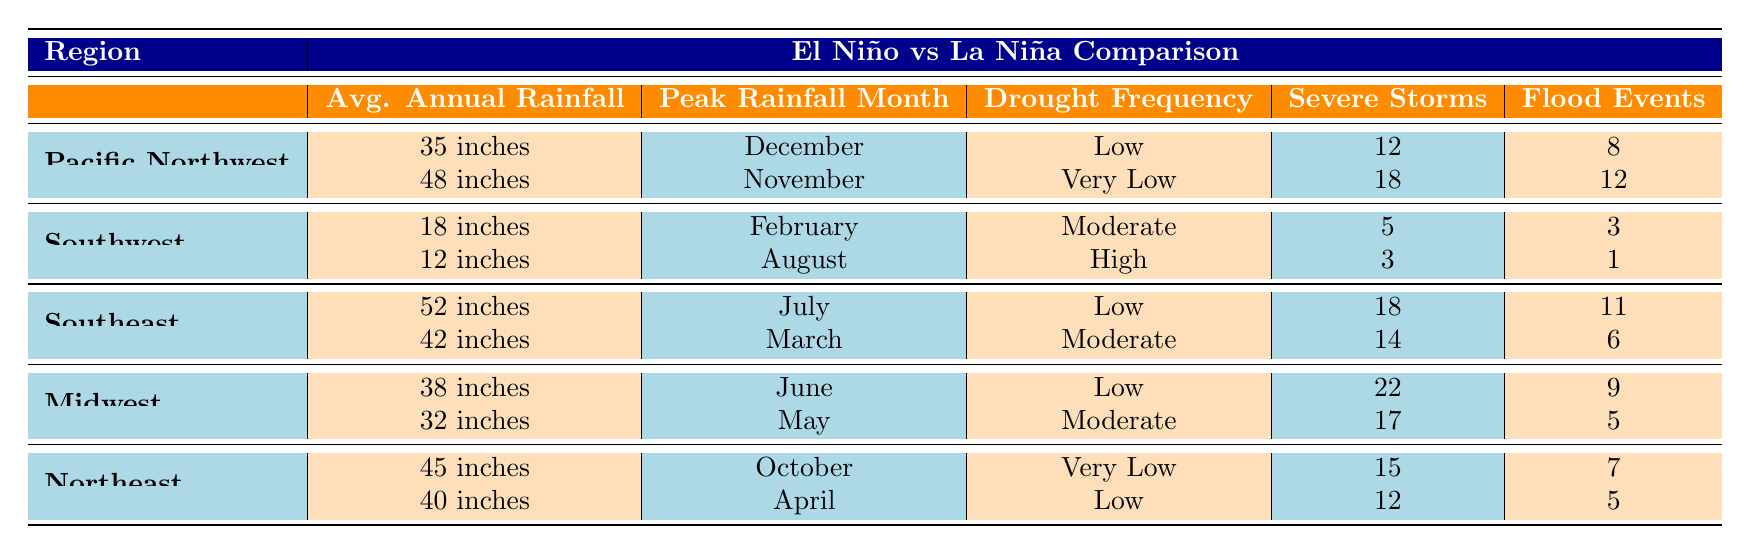What is the average annual rainfall in the Southeast during El Niño years? In the table, the average annual rainfall for the Southeast during El Niño years is listed as 52 inches.
Answer: 52 inches Which region experiences the highest drought frequency during La Niña? According to the table, the Southwest experiences a high drought frequency during La Niña years.
Answer: Southwest How many severe storm occurrences were recorded in the Midwest during El Niño years? The table shows that there were 22 severe storm occurrences in the Midwest during El Niño years.
Answer: 22 What is the difference in average annual rainfall between the Pacific Northwest during El Niño and La Niña years? The average annual rainfall during El Niño in the Pacific Northwest is 35 inches and during La Niña is 48 inches. To find the difference: 48 - 35 = 13 inches.
Answer: 13 inches In which month does the peak rainfall occur in the Northeast during La Niña years? The table specifies that the peak rainfall month in the Northeast during La Niña years is April.
Answer: April Does the Southeast experience more flood events during El Niño than during La Niña? The table shows 11 flood events during El Niño and 6 flood events during La Niña in the Southeast. Therefore, the Southeast does experience more flood events during El Niño.
Answer: Yes Which region has the lowest average annual rainfall during La Niña? The Southwest has the lowest average annual rainfall during La Niña at 12 inches, as indicated in the table.
Answer: Southwest How many severe storm occurrences are reported in the Southeast during La Niña years compared to El Niño years? For La Niña years, the Southeastern region reported 14 severe storm occurrences, while during El Niño, it reported 18 occurrences. The difference is small: 18 - 14 = 4 more occurrences in El Niño years.
Answer: 4 What is the correlation between severe storm occurrences and flood events in the Midwest during El Niño? The table indicates 22 severe storm occurrences and 9 flood events in the Midwest during El Niño. While the exact correlation can't be determined from these values alone without further analysis, we see a relatively high number of severe storms compared to flood events, suggesting not every severe storm leads to flooding.
Answer: Not directly determinable 